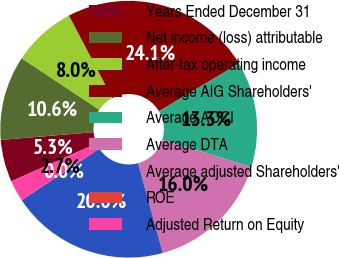<chart> <loc_0><loc_0><loc_500><loc_500><pie_chart><fcel>Years Ended December 31<fcel>Net income (loss) attributable<fcel>After-tax operating income<fcel>Average AIG Shareholders'<fcel>Average AOCI<fcel>Average DTA<fcel>Average adjusted Shareholders'<fcel>ROE<fcel>Adjusted Return on Equity<nl><fcel>5.32%<fcel>10.65%<fcel>7.98%<fcel>24.15%<fcel>13.31%<fcel>15.97%<fcel>19.96%<fcel>0.0%<fcel>2.66%<nl></chart> 